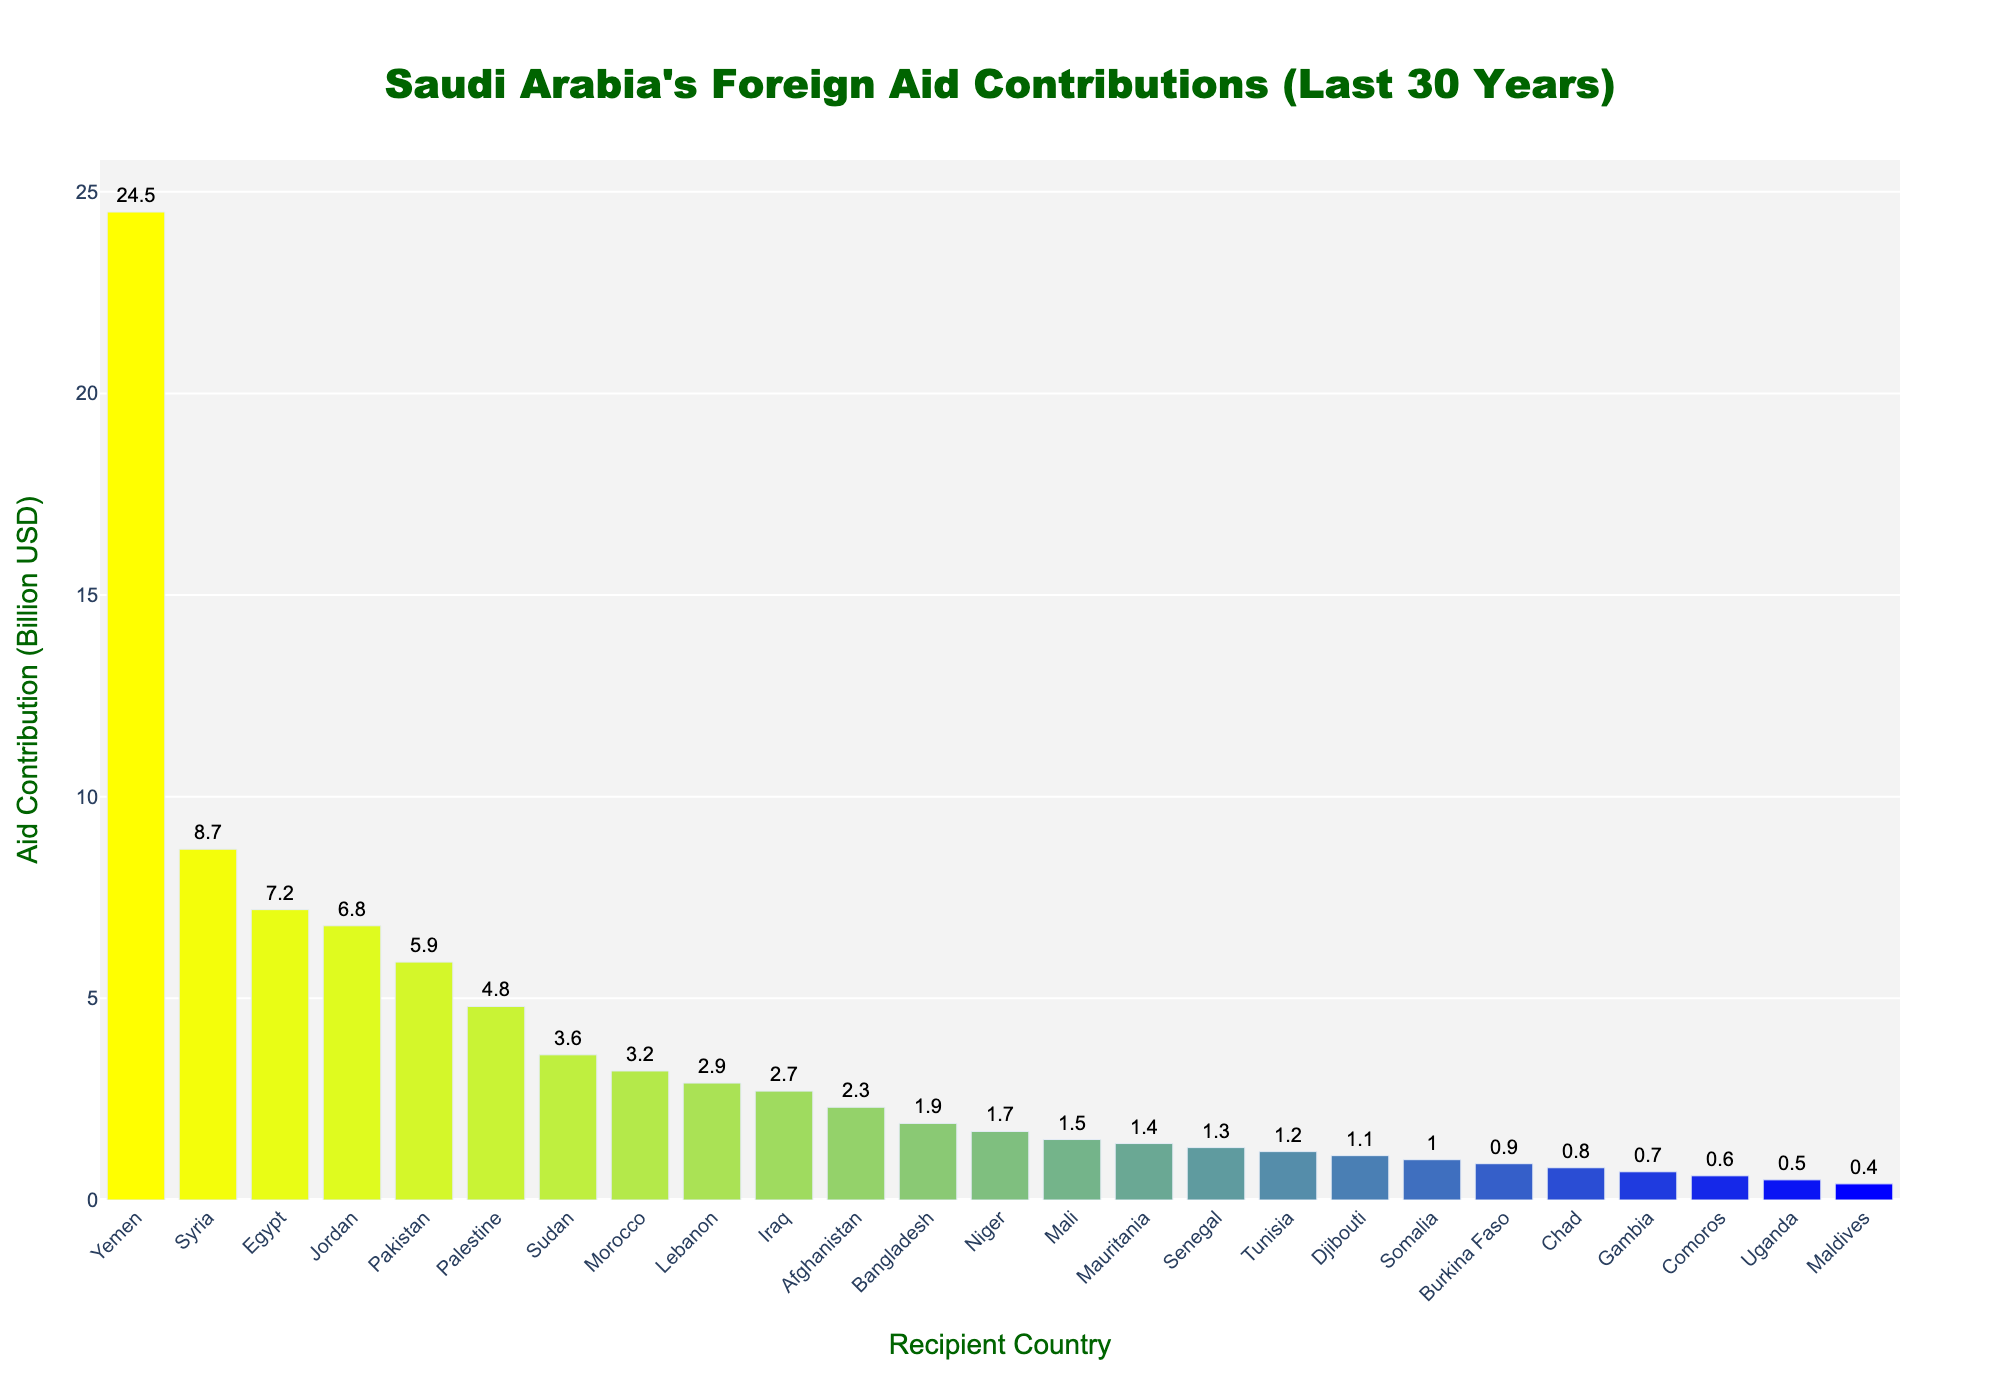What's the total aid contribution to Yemen, Syria, and Egypt? Add the aid contributions for Yemen (24.5 billion USD), Syria (8.7 billion USD), and Egypt (7.2 billion USD). Therefore, the total aid is 24.5 + 8.7 + 7.2 = 40.4 billion USD.
Answer: 40.4 billion USD Which country received more aid, Palestine or Sudan? Comparing the aid contribution for Palestine (4.8 billion USD) with that for Sudan (3.6 billion USD), Palestine received more aid.
Answer: Palestine What's the difference in aid contribution between Jordan and Pakistan? Subtract Pakistan's aid contribution (5.9 billion USD) from Jordan's (6.8 billion USD). So, the difference is 6.8 - 5.9 = 0.9 billion USD.
Answer: 0.9 billion USD Which country has the shortest bar in the chart representing aid contribution? The Gambia, with 0.7 billion USD, has the shortest bar in the chart.
Answer: The Gambia What's the average aid contribution to Afghanistan, Bangladesh, and Niger? Add the aid contributions for Afghanistan (2.3 billion USD), Bangladesh (1.9 billion USD), and Niger (1.7 billion USD), then divide by 3. The total is 2.3 + 1.9 + 1.7 = 5.9 billion USD, and the average is 5.9 / 3 = 1.97 billion USD.
Answer: 1.97 billion USD Compare the aid contributions of Morocco and Lebanon. Which country received more? Morocco received 3.2 billion USD in aid, while Lebanon received 2.9 billion USD. Therefore, Morocco received more aid.
Answer: Morocco Which countries received more than 5 billion USD in aid? Yemen, Syria, Egypt, Jordan, and Pakistan received aid amounts greater than 5 billion USD.
Answer: Yemen, Syria, Egypt, Jordan, Pakistan What's the sum of the aid contributions to Tunisia, Djibouti, and Somalia? Add the aid contributions for Tunisia (1.2 billion USD), Djibouti (1.1 billion USD), and Somalia (1.0 billion USD). So, the total is 1.2 + 1.1 + 1.0 = 3.3 billion USD.
Answer: 3.3 billion USD How much more aid did Mauritania receive compared to Chad? Subtract Chad's aid contribution (0.8 billion USD) from Mauritania's (1.4 billion USD). The difference is 1.4 - 0.8 = 0.6 billion USD.
Answer: 0.6 billion USD What's the average aid contribution for the top three recipient countries? Add the aid contributions for Yemen (24.5 billion USD), Syria (8.7 billion USD), and Egypt (7.2 billion USD), then divide by 3. The total is 24.5 + 8.7 + 7.2 = 40.4 billion USD, and the average is 40.4 / 3 = 13.47 billion USD.
Answer: 13.47 billion USD 